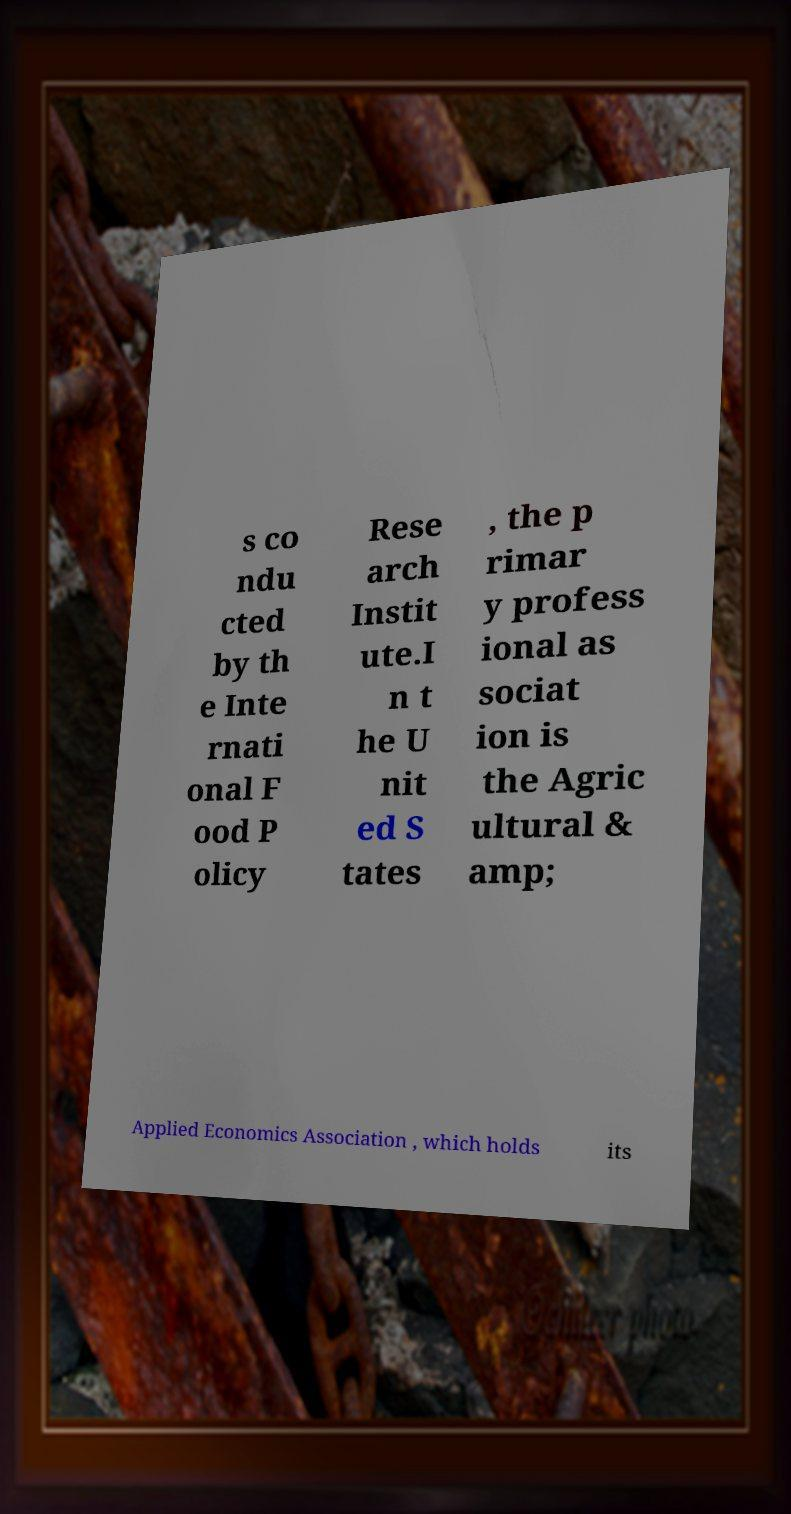Could you assist in decoding the text presented in this image and type it out clearly? s co ndu cted by th e Inte rnati onal F ood P olicy Rese arch Instit ute.I n t he U nit ed S tates , the p rimar y profess ional as sociat ion is the Agric ultural & amp; Applied Economics Association , which holds its 